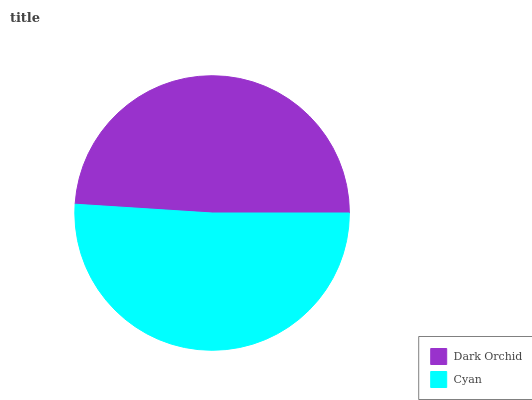Is Dark Orchid the minimum?
Answer yes or no. Yes. Is Cyan the maximum?
Answer yes or no. Yes. Is Cyan the minimum?
Answer yes or no. No. Is Cyan greater than Dark Orchid?
Answer yes or no. Yes. Is Dark Orchid less than Cyan?
Answer yes or no. Yes. Is Dark Orchid greater than Cyan?
Answer yes or no. No. Is Cyan less than Dark Orchid?
Answer yes or no. No. Is Cyan the high median?
Answer yes or no. Yes. Is Dark Orchid the low median?
Answer yes or no. Yes. Is Dark Orchid the high median?
Answer yes or no. No. Is Cyan the low median?
Answer yes or no. No. 